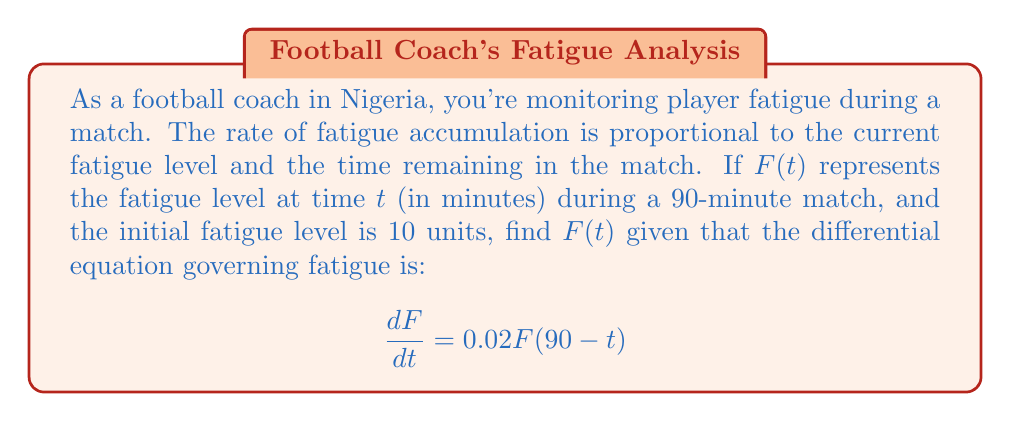Show me your answer to this math problem. Let's solve this step-by-step:

1) We have the differential equation: $\frac{dF}{dt} = 0.02F(90-t)$

2) This is a separable equation. Let's rearrange it:
   $$\frac{dF}{F} = 0.02(90-t)dt$$

3) Integrate both sides:
   $$\int \frac{dF}{F} = \int 0.02(90-t)dt$$

4) Solving the integrals:
   $$\ln|F| = 0.02(90t - \frac{t^2}{2}) + C$$

5) Simplify:
   $$\ln|F| = 1.8t - 0.01t^2 + C$$

6) Exponentiate both sides:
   $$F = e^{1.8t - 0.01t^2 + C} = Ae^{1.8t - 0.01t^2}$$
   where $A = e^C$ is a constant.

7) Use the initial condition $F(0) = 10$ to find $A$:
   $$10 = Ae^{1.8(0) - 0.01(0)^2} = A$$

8) Therefore, the general solution is:
   $$F(t) = 10e^{1.8t - 0.01t^2}$$

This function represents the fatigue level at any time $t$ during the match.
Answer: $F(t) = 10e^{1.8t - 0.01t^2}$ 